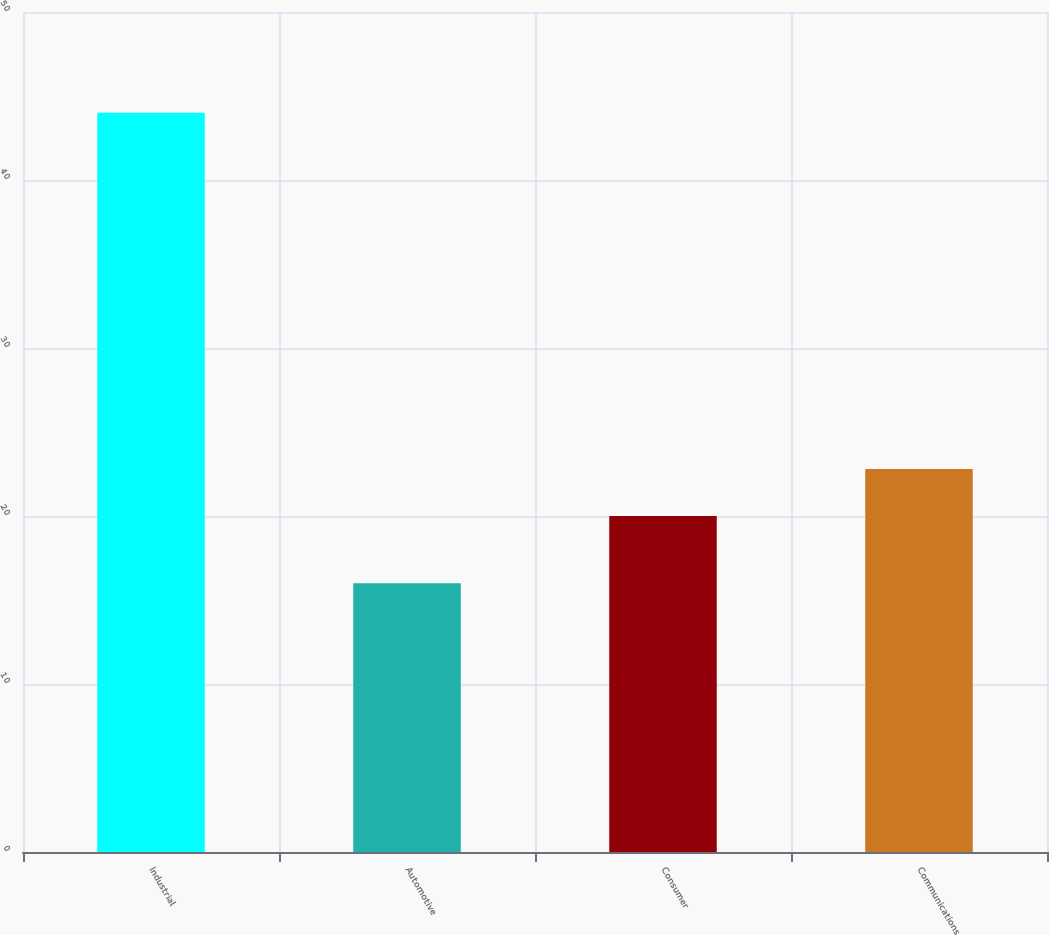Convert chart. <chart><loc_0><loc_0><loc_500><loc_500><bar_chart><fcel>Industrial<fcel>Automotive<fcel>Consumer<fcel>Communications<nl><fcel>44<fcel>16<fcel>20<fcel>22.8<nl></chart> 